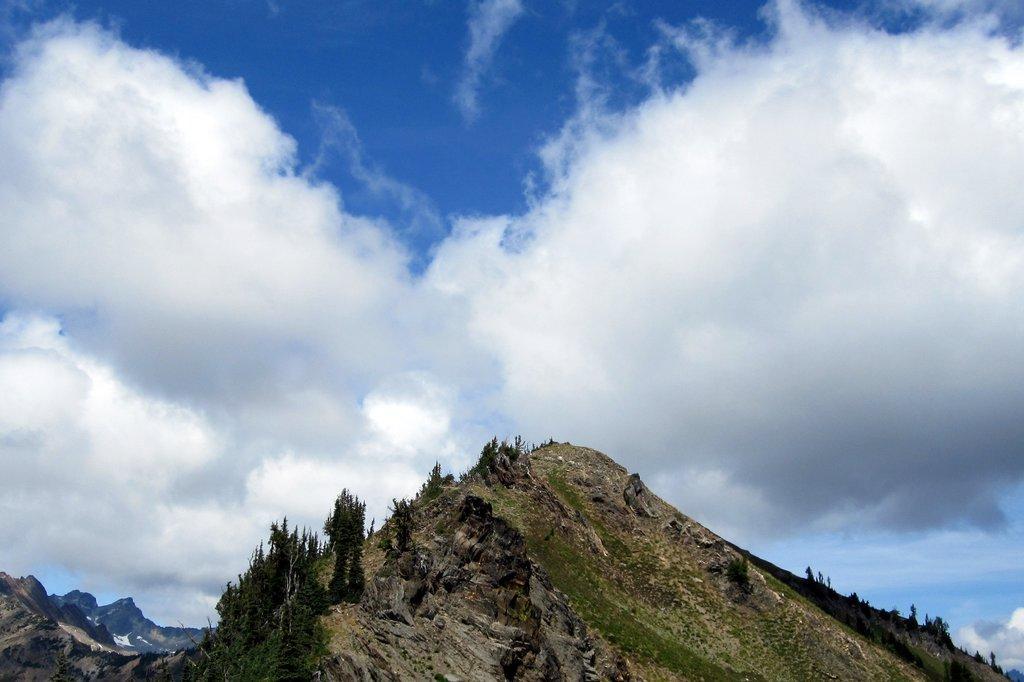Can you describe this image briefly? In this picture I can see the mountains on which there are number of trees and in the background I can see the sky, which is a bit cloudy. 